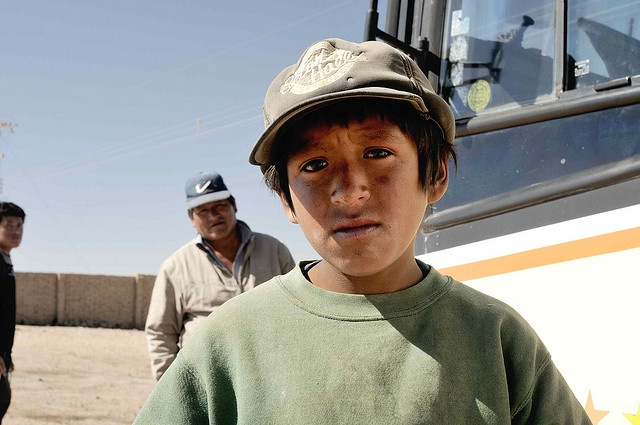Describe the objects in this image and their specific colors. I can see people in darkgray, black, darkgreen, and beige tones, bus in darkgray, white, gray, and black tones, people in darkgray, lightgray, gray, black, and maroon tones, and people in darkgray, black, gray, maroon, and lightgray tones in this image. 